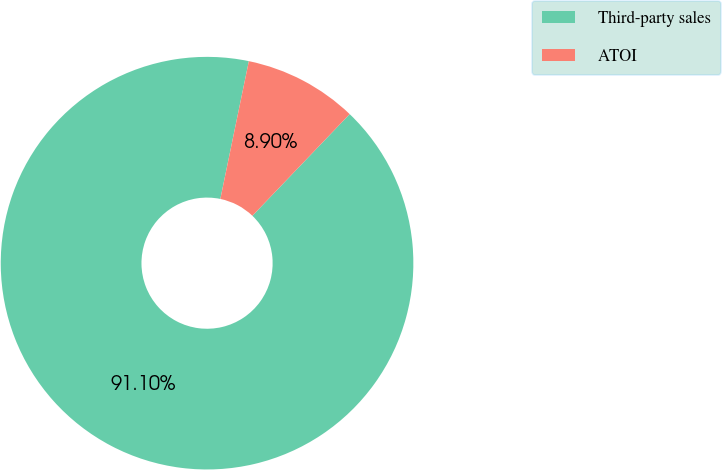<chart> <loc_0><loc_0><loc_500><loc_500><pie_chart><fcel>Third-party sales<fcel>ATOI<nl><fcel>91.1%<fcel>8.9%<nl></chart> 